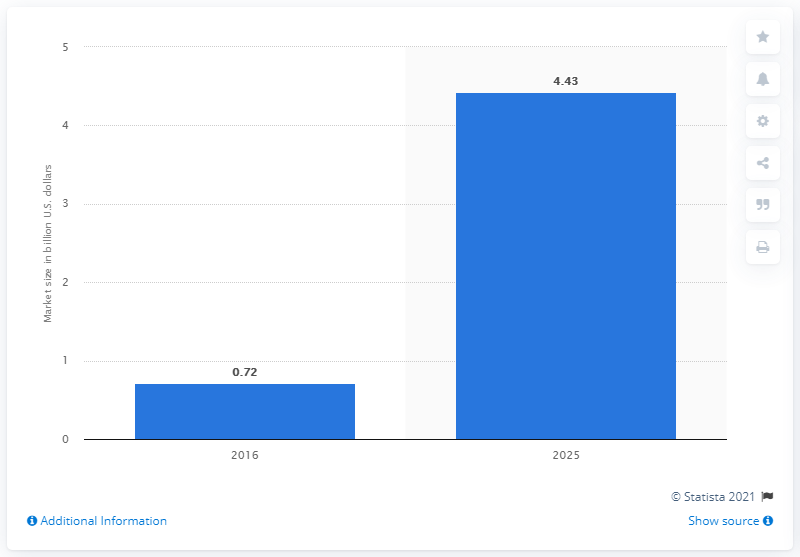Indicate a few pertinent items in this graphic. The estimated value of the liquid biopsy market in 2025 is approximately 4.43 dollars. In 2016, the liquid biopsy market was approximately 0.72. The global liquid biopsy market is forecasted to reach its peak in 2025. 